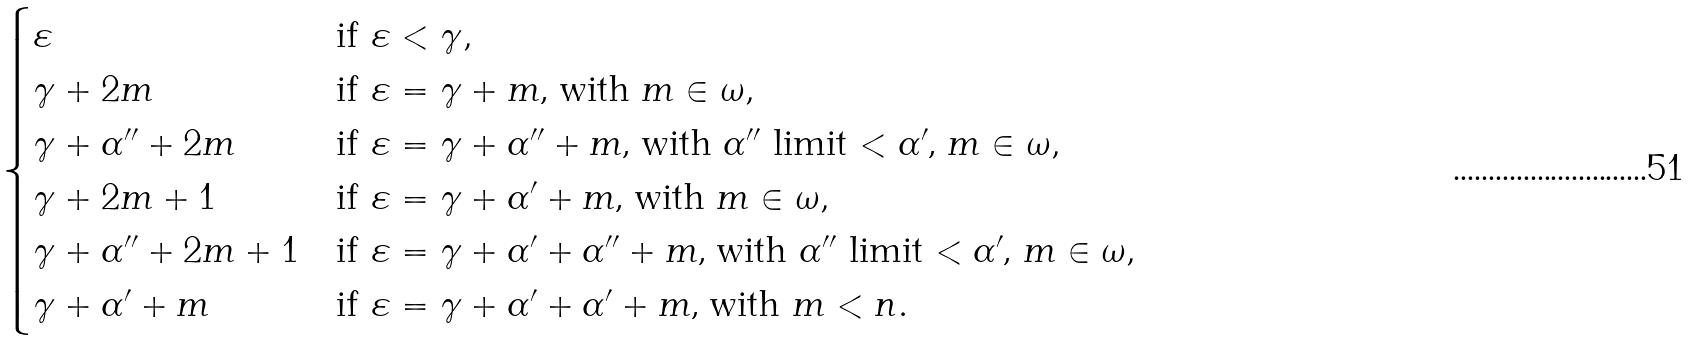Convert formula to latex. <formula><loc_0><loc_0><loc_500><loc_500>\begin{cases} \varepsilon & \text {if $ \varepsilon < \gamma $} , \\ \gamma + 2 m & \text {if $ \varepsilon = \gamma + m $, with $m \in \omega $} , \\ \gamma + \alpha ^ { \prime \prime } + 2 m & \text {if $ \varepsilon = \gamma + \alpha^{\prime\prime}+m $, with $ \alpha ^{\prime\prime}$ limit $ < \alpha^{\prime}$,  $m \in \omega $} , \\ \gamma + 2 m + 1 & \text {if $ \varepsilon = \gamma + \alpha^{\prime}+m $, with $m \in \omega $} , \\ \gamma + \alpha ^ { \prime \prime } + 2 m + 1 & \text {if $ \varepsilon = \gamma + \alpha^{\prime}+ \alpha^{\prime\prime}+m $, } \text {with $ \alpha ^{\prime\prime}$ limit $ < \alpha^{\prime}$, $m \in \omega $} , \\ \gamma + \alpha ^ { \prime } + m & \text {if $ \varepsilon = \gamma + \alpha^{\prime}+ \alpha^{\prime}+m $, with  $m < n$} . \\ \end{cases}</formula> 